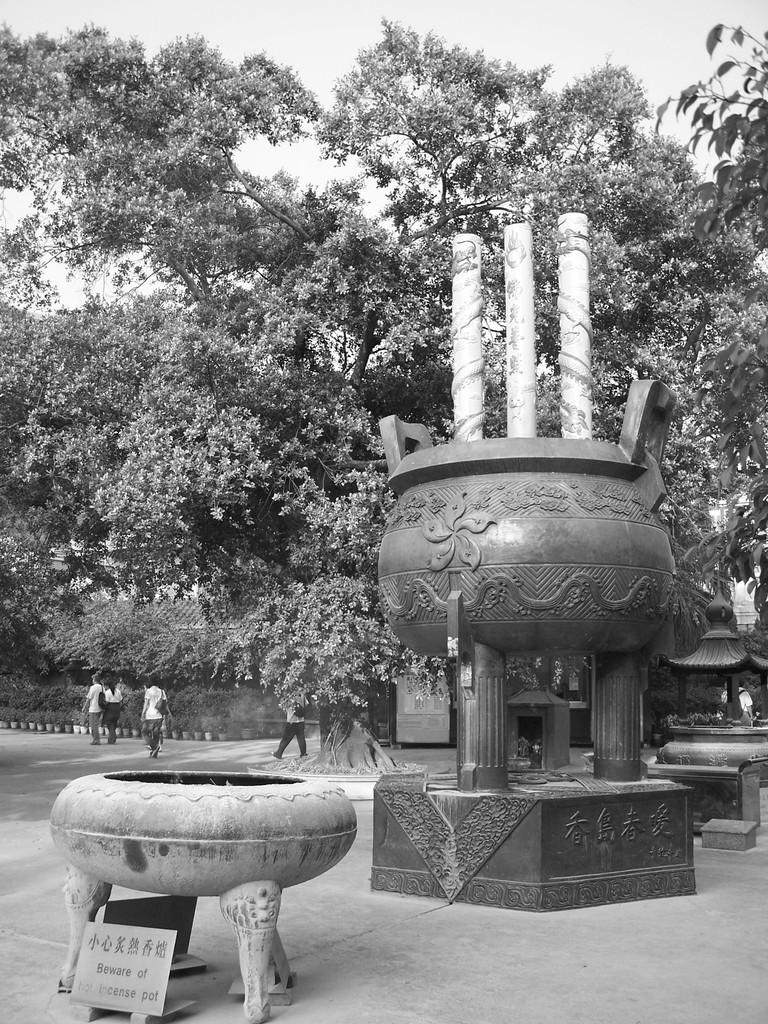What type of objects can be seen in the image? There are statues ines in the image. Is there any additional information provided in the image? Yes, there is an information board in the image. What type of natural elements are present in the image? There are trees in the image. Are there any people visible in the image? Yes, there are people in the image. What can be seen in the background of the image? The sky is visible in the background of the image. What type of toys are the statues playing with in the image? There are no toys present in the image; it features statues, an information board, trees, people, and a visible sky. What is the scale of the writer's desk in the image? There is no writer or desk present in the image. 